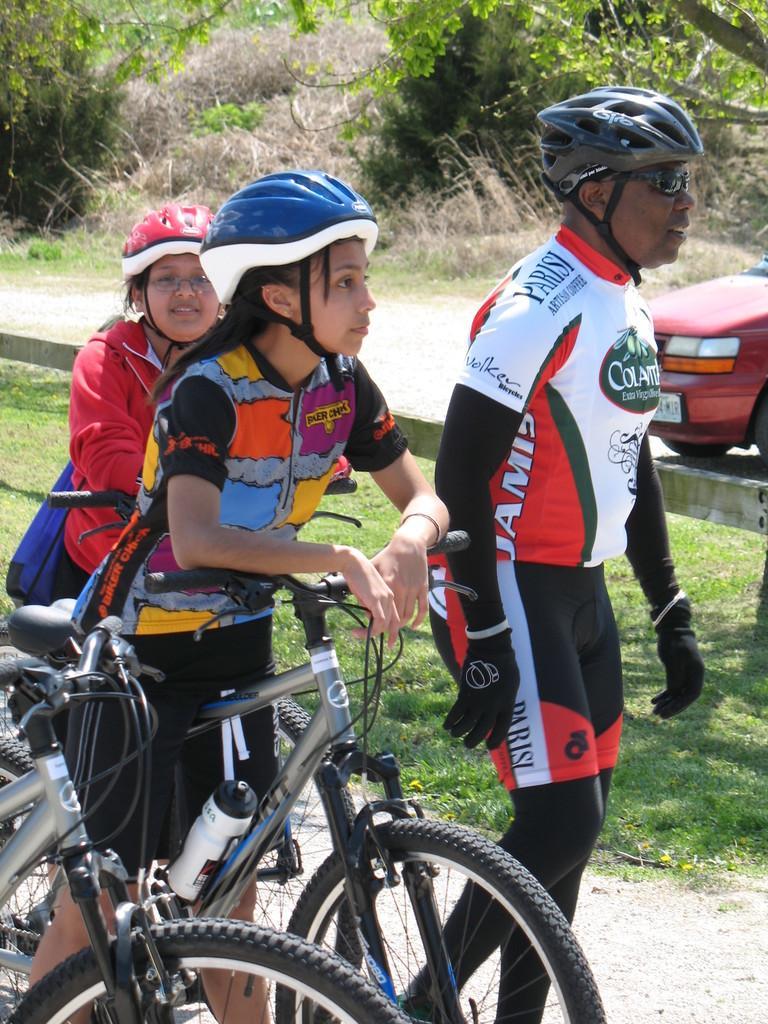How would you summarize this image in a sentence or two? In this picture we can observe three members. All of them are wearing helmets on their heads. There are two bicycles on the road. On the right side we can observe red color car. There is some grass on the ground. In the background there are trees. 